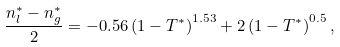<formula> <loc_0><loc_0><loc_500><loc_500>\frac { n _ { l } ^ { \ast } - n _ { g } ^ { \ast } } { 2 } = - 0 . 5 6 \left ( 1 - T ^ { \ast } \right ) ^ { 1 . 5 3 } + 2 \left ( 1 - T ^ { \ast } \right ) ^ { 0 . 5 } ,</formula> 